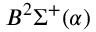<formula> <loc_0><loc_0><loc_500><loc_500>B ^ { 2 } \Sigma ^ { + } ( \alpha )</formula> 